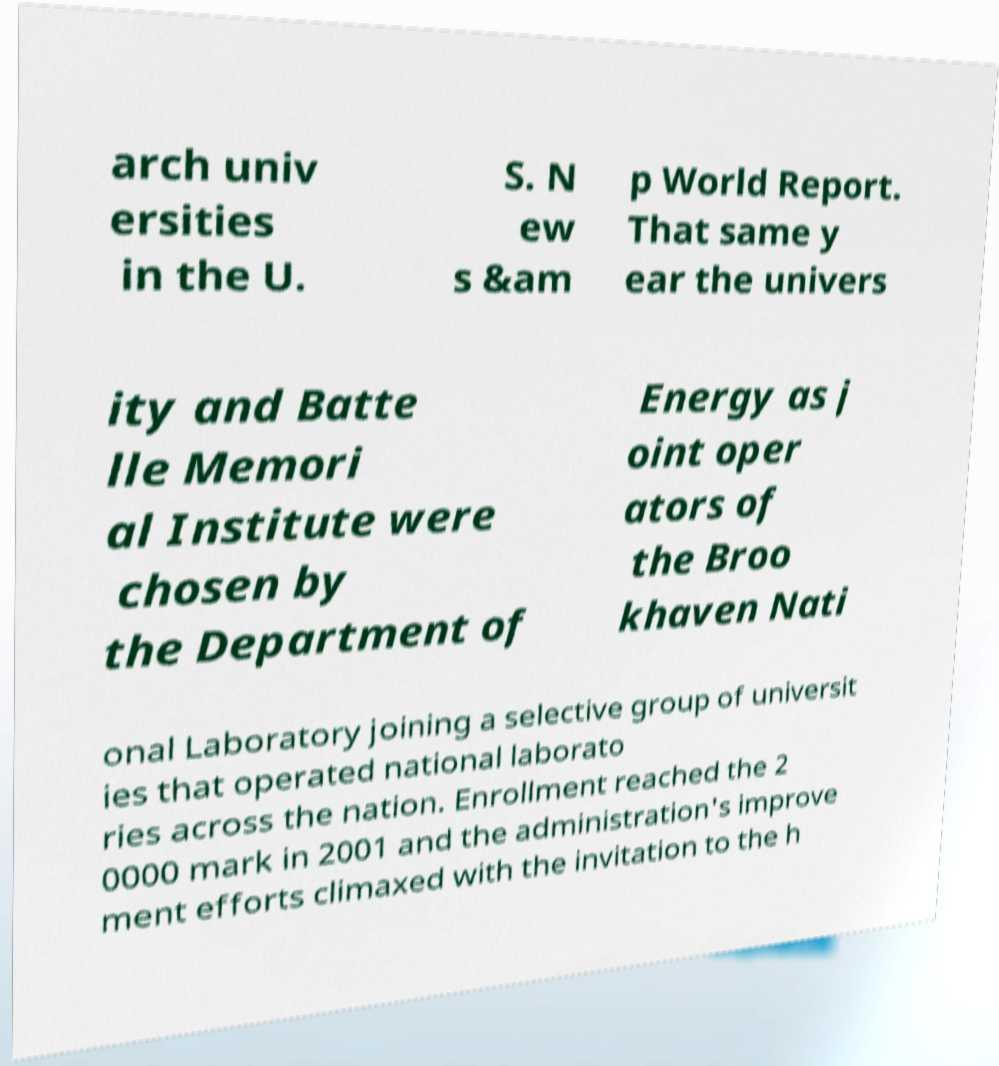Could you extract and type out the text from this image? arch univ ersities in the U. S. N ew s &am p World Report. That same y ear the univers ity and Batte lle Memori al Institute were chosen by the Department of Energy as j oint oper ators of the Broo khaven Nati onal Laboratory joining a selective group of universit ies that operated national laborato ries across the nation. Enrollment reached the 2 0000 mark in 2001 and the administration's improve ment efforts climaxed with the invitation to the h 